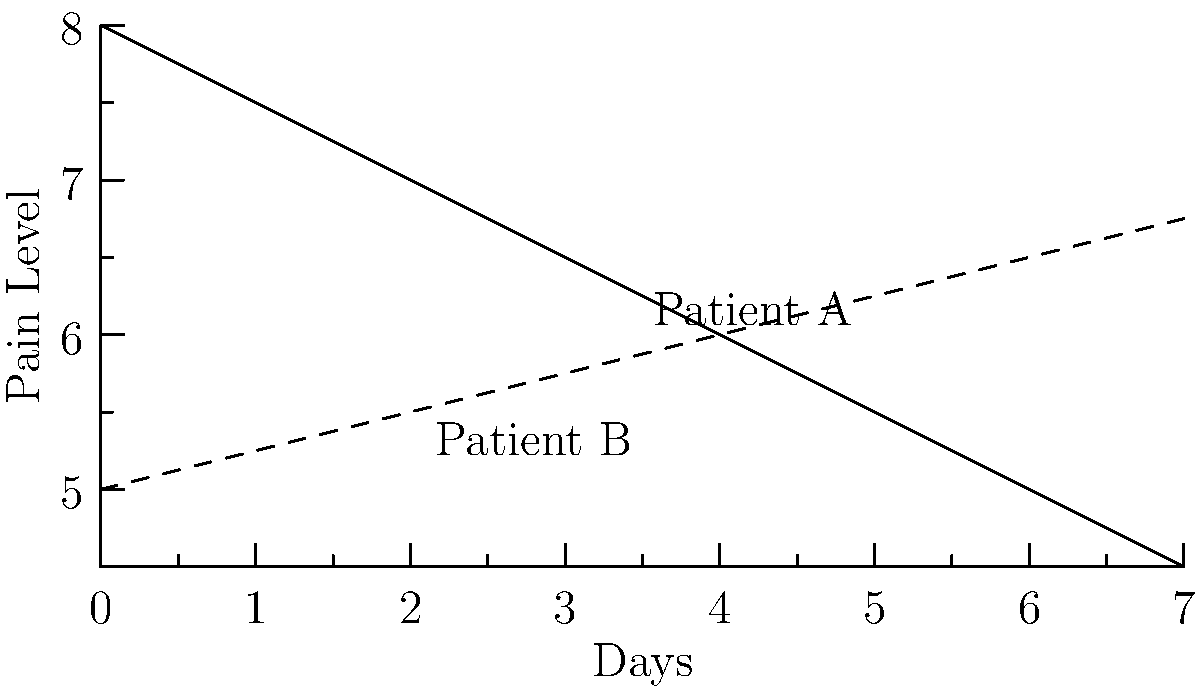The line graph shows the pain levels of two terminally ill patients over a week. Patient A's pain level starts at 8 and decreases by 0.5 units per day, while Patient B's pain level starts at 5 and increases by 0.25 units per day. On which day do both patients experience the same level of pain? To find the day when both patients experience the same level of pain, we need to determine when their pain levels intersect. Let's approach this step-by-step:

1. Set up equations for each patient's pain level:
   Patient A: $y_A = 8 - 0.5x$
   Patient B: $y_B = 5 + 0.25x$
   Where $y$ is the pain level and $x$ is the number of days.

2. To find the intersection, set the equations equal to each other:
   $8 - 0.5x = 5 + 0.25x$

3. Solve for $x$:
   $8 - 5 = 0.25x + 0.5x$
   $3 = 0.75x$
   $x = 3 / 0.75 = 4$

4. Verify the pain level at day 4:
   Patient A: $8 - 0.5(4) = 6$
   Patient B: $5 + 0.25(4) = 6$

Therefore, both patients experience the same level of pain (6) on day 4.
Answer: Day 4 